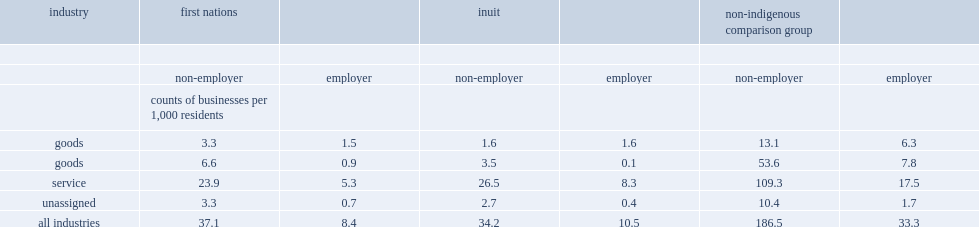Which group have the highest counts per resident for both non-employers and employers in every industry grouping? Non-indigenous comparison group. 